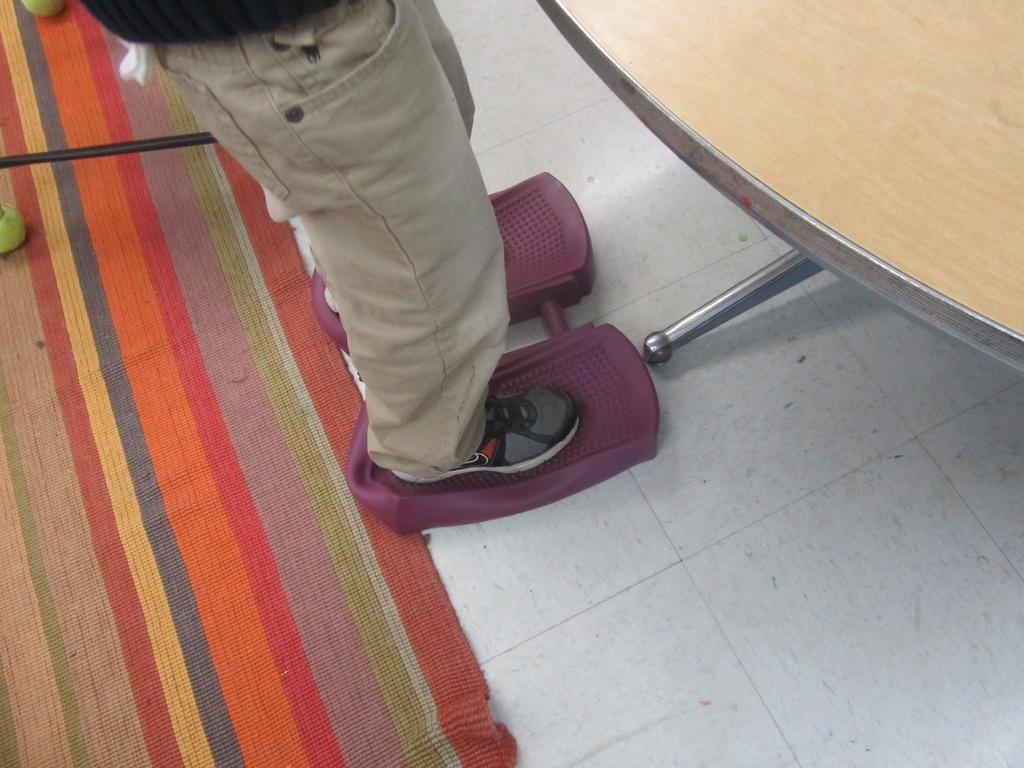What is the main subject of the image? There is a person standing in the image. What can be seen on the person's feet? The person is wearing shoes. What type of surface is present in the image? There is a wooden surface in the image. What is beneath the person's feet? There is a floor visible in the image. How many pies are being led by the person in the image? There are no pies or any indication of leading in the image. 